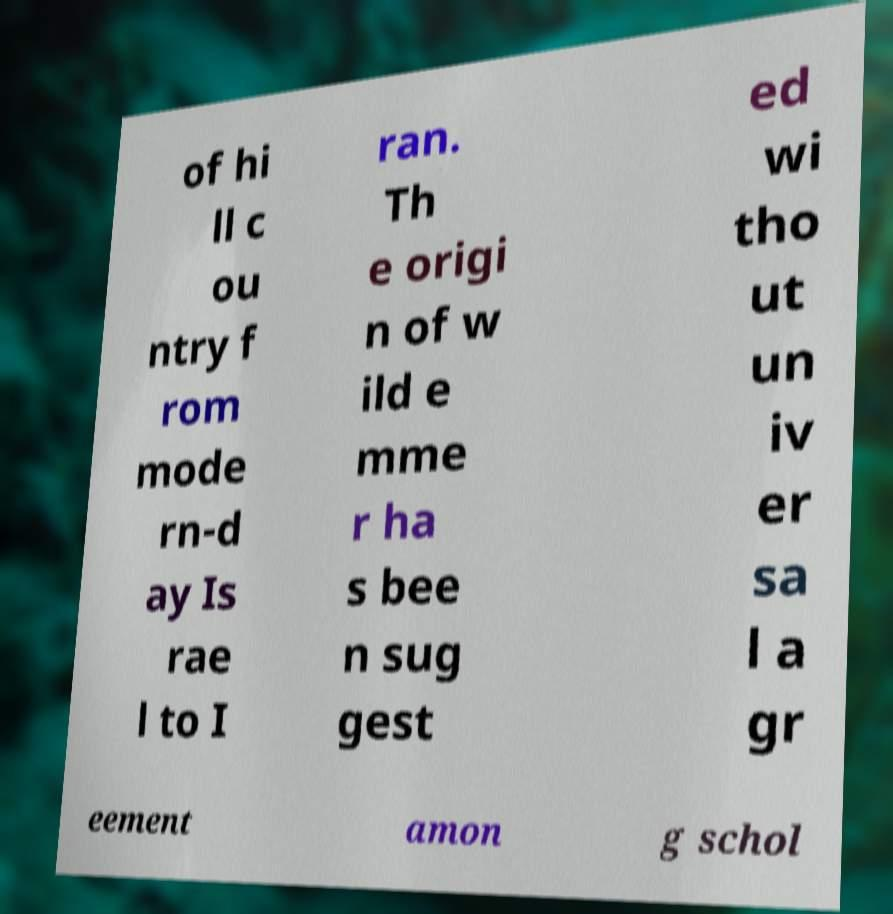Could you assist in decoding the text presented in this image and type it out clearly? of hi ll c ou ntry f rom mode rn-d ay Is rae l to I ran. Th e origi n of w ild e mme r ha s bee n sug gest ed wi tho ut un iv er sa l a gr eement amon g schol 